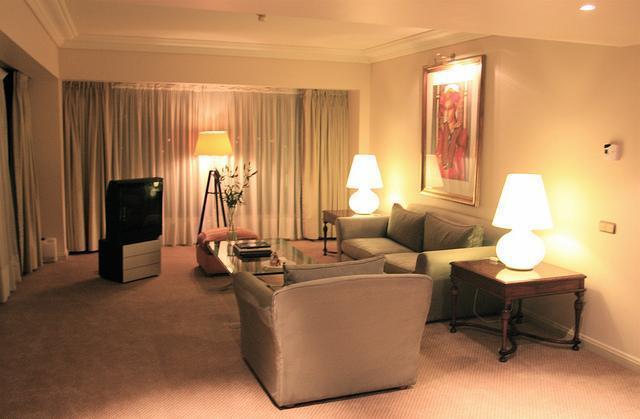How many lamps are on?
Give a very brief answer. 3. 